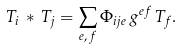Convert formula to latex. <formula><loc_0><loc_0><loc_500><loc_500>T _ { i } \, * \, T _ { j } = \sum _ { e , \, f } \Phi _ { i j e } \, g ^ { e f } \, T _ { f } .</formula> 